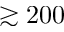<formula> <loc_0><loc_0><loc_500><loc_500>\gtrsim 2 0 0</formula> 